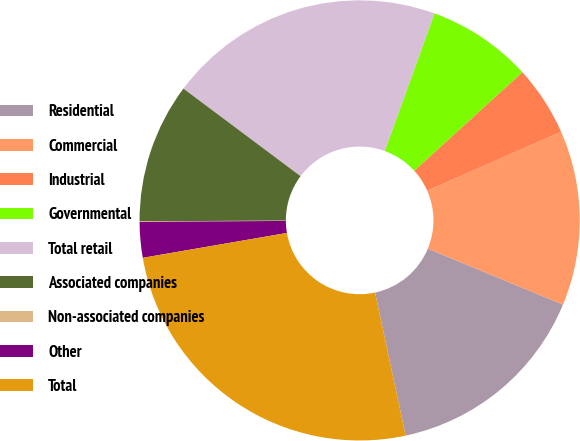<chart> <loc_0><loc_0><loc_500><loc_500><pie_chart><fcel>Residential<fcel>Commercial<fcel>Industrial<fcel>Governmental<fcel>Total retail<fcel>Associated companies<fcel>Non-associated companies<fcel>Other<fcel>Total<nl><fcel>15.4%<fcel>12.84%<fcel>5.17%<fcel>7.72%<fcel>20.3%<fcel>10.28%<fcel>0.05%<fcel>2.61%<fcel>25.63%<nl></chart> 